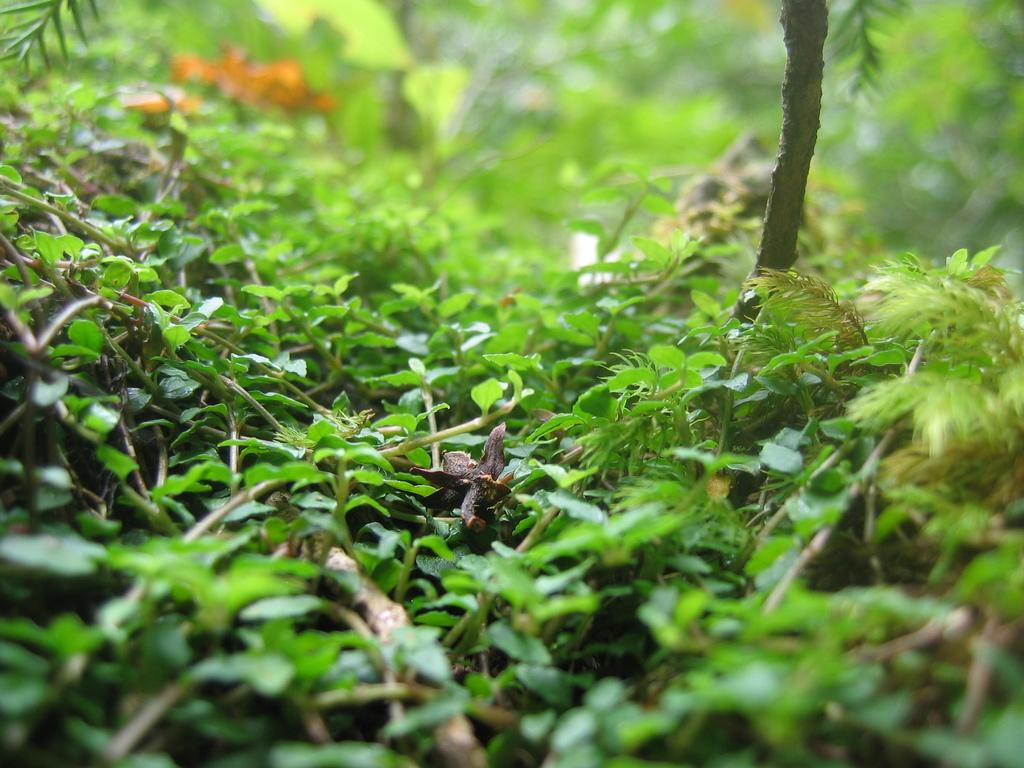What type of living organisms can be seen in the image? Plants can be seen in the image. Can you describe the background of the image? The background of the image is blurred. What route does the mother take with the donkey in the image? There is no mother or donkey present in the image, so it is not possible to determine a route. 